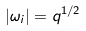Convert formula to latex. <formula><loc_0><loc_0><loc_500><loc_500>| \omega _ { i } | = q ^ { 1 / 2 }</formula> 